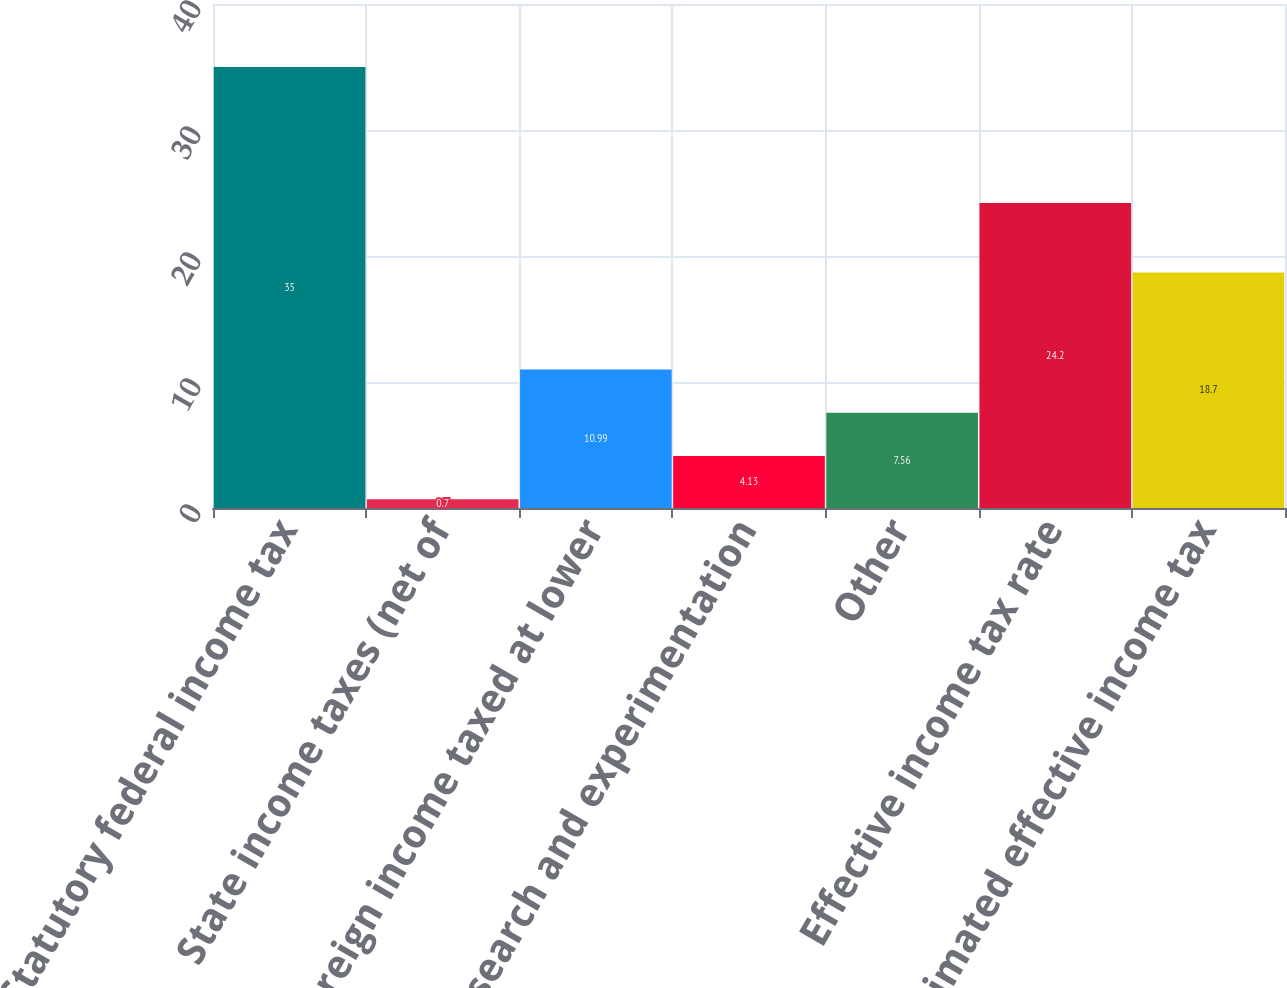Convert chart. <chart><loc_0><loc_0><loc_500><loc_500><bar_chart><fcel>Statutory federal income tax<fcel>State income taxes (net of<fcel>Foreign income taxed at lower<fcel>Research and experimentation<fcel>Other<fcel>Effective income tax rate<fcel>Estimated effective income tax<nl><fcel>35<fcel>0.7<fcel>10.99<fcel>4.13<fcel>7.56<fcel>24.2<fcel>18.7<nl></chart> 